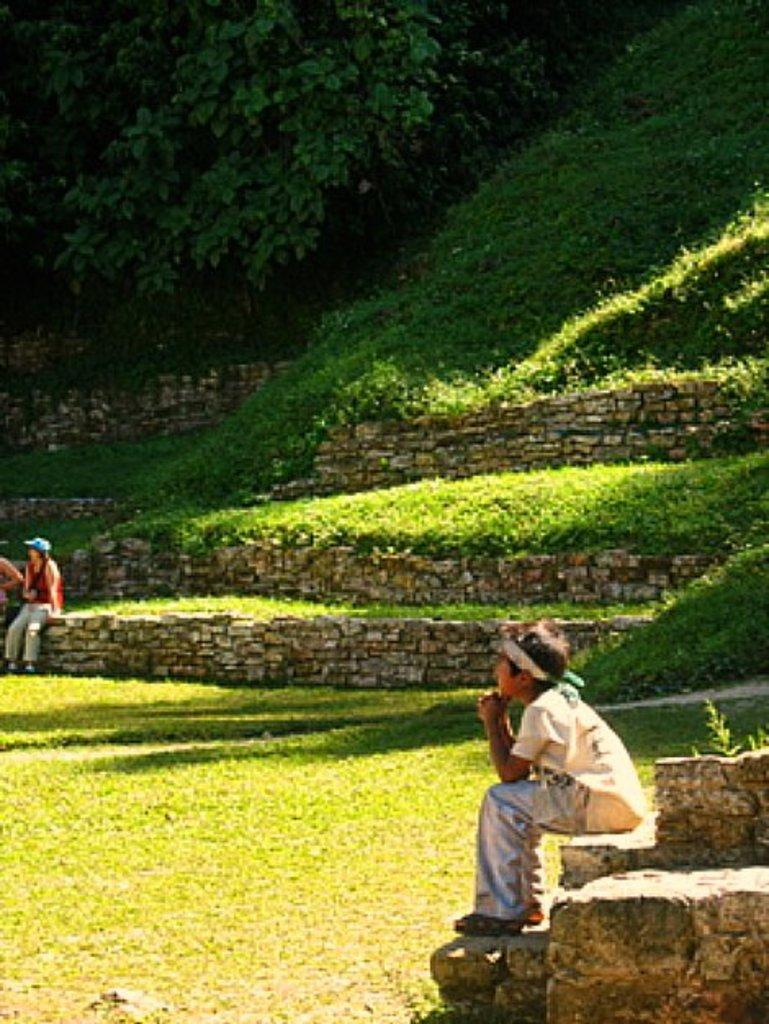What is the ground surface like in the image? The ground in the image is covered with grass. What are the people in the image doing? There are people sitting in the image. What type of vegetation can be seen in the image? Plants and trees are present in the image. What type of offer is being made by the tree in the image? There is no offer being made by the tree in the image, as trees do not make offers. 